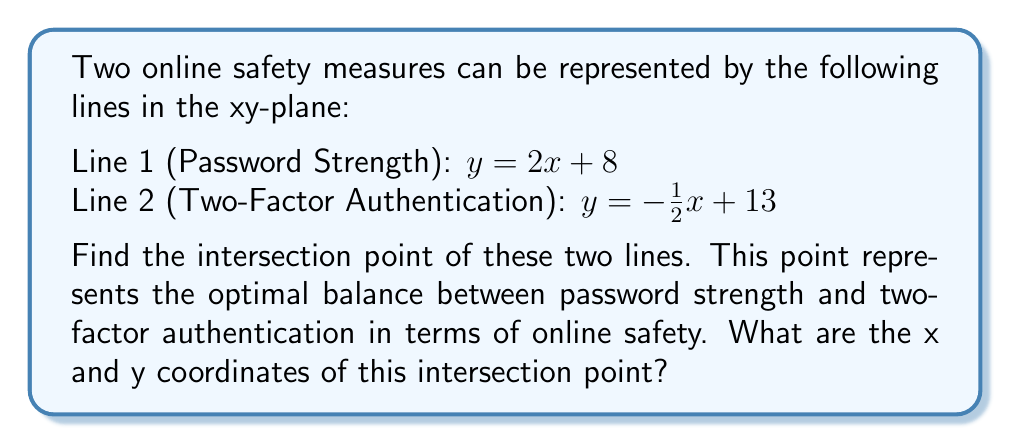Could you help me with this problem? To find the intersection point of two lines, we need to solve the system of equations formed by the two lines:

$$\begin{cases}
y = 2x + 8 \\
y = -\frac{1}{2}x + 13
\end{cases}$$

Since both equations are equal to y, we can set them equal to each other:

$$2x + 8 = -\frac{1}{2}x + 13$$

Now, let's solve for x:

1) Add $\frac{1}{2}x$ to both sides:
   $$2x + \frac{1}{2}x + 8 = 13$$
   $$\frac{5}{2}x + 8 = 13$$

2) Subtract 8 from both sides:
   $$\frac{5}{2}x = 5$$

3) Multiply both sides by $\frac{2}{5}$:
   $$x = 2$$

Now that we have x, we can substitute it into either of the original equations to find y. Let's use the first equation:

$$y = 2x + 8$$
$$y = 2(2) + 8$$
$$y = 4 + 8 = 12$$

Therefore, the intersection point is (2, 12).

[asy]
unitsize(1cm);
draw((-1,6)--(5,18),red);
draw((-1,13.5)--(7,9.5),blue);
dot((2,12));
label("(2, 12)", (2,12), NE);
label("Password Strength", (4,16), E, red);
label("Two-Factor Authentication", (6,10), E, blue);
[/asy]
Answer: The intersection point is (2, 12). 